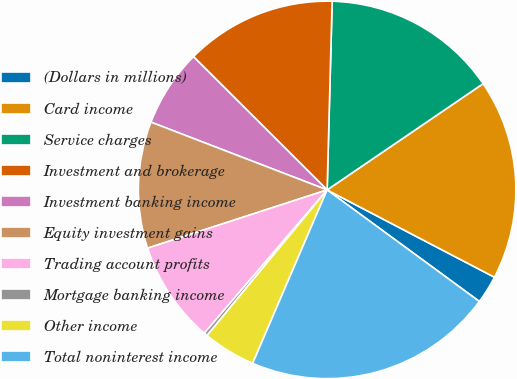Convert chart. <chart><loc_0><loc_0><loc_500><loc_500><pie_chart><fcel>(Dollars in millions)<fcel>Card income<fcel>Service charges<fcel>Investment and brokerage<fcel>Investment banking income<fcel>Equity investment gains<fcel>Trading account profits<fcel>Mortgage banking income<fcel>Other income<fcel>Total noninterest income<nl><fcel>2.41%<fcel>17.17%<fcel>15.06%<fcel>12.95%<fcel>6.63%<fcel>10.84%<fcel>8.73%<fcel>0.3%<fcel>4.52%<fcel>21.39%<nl></chart> 